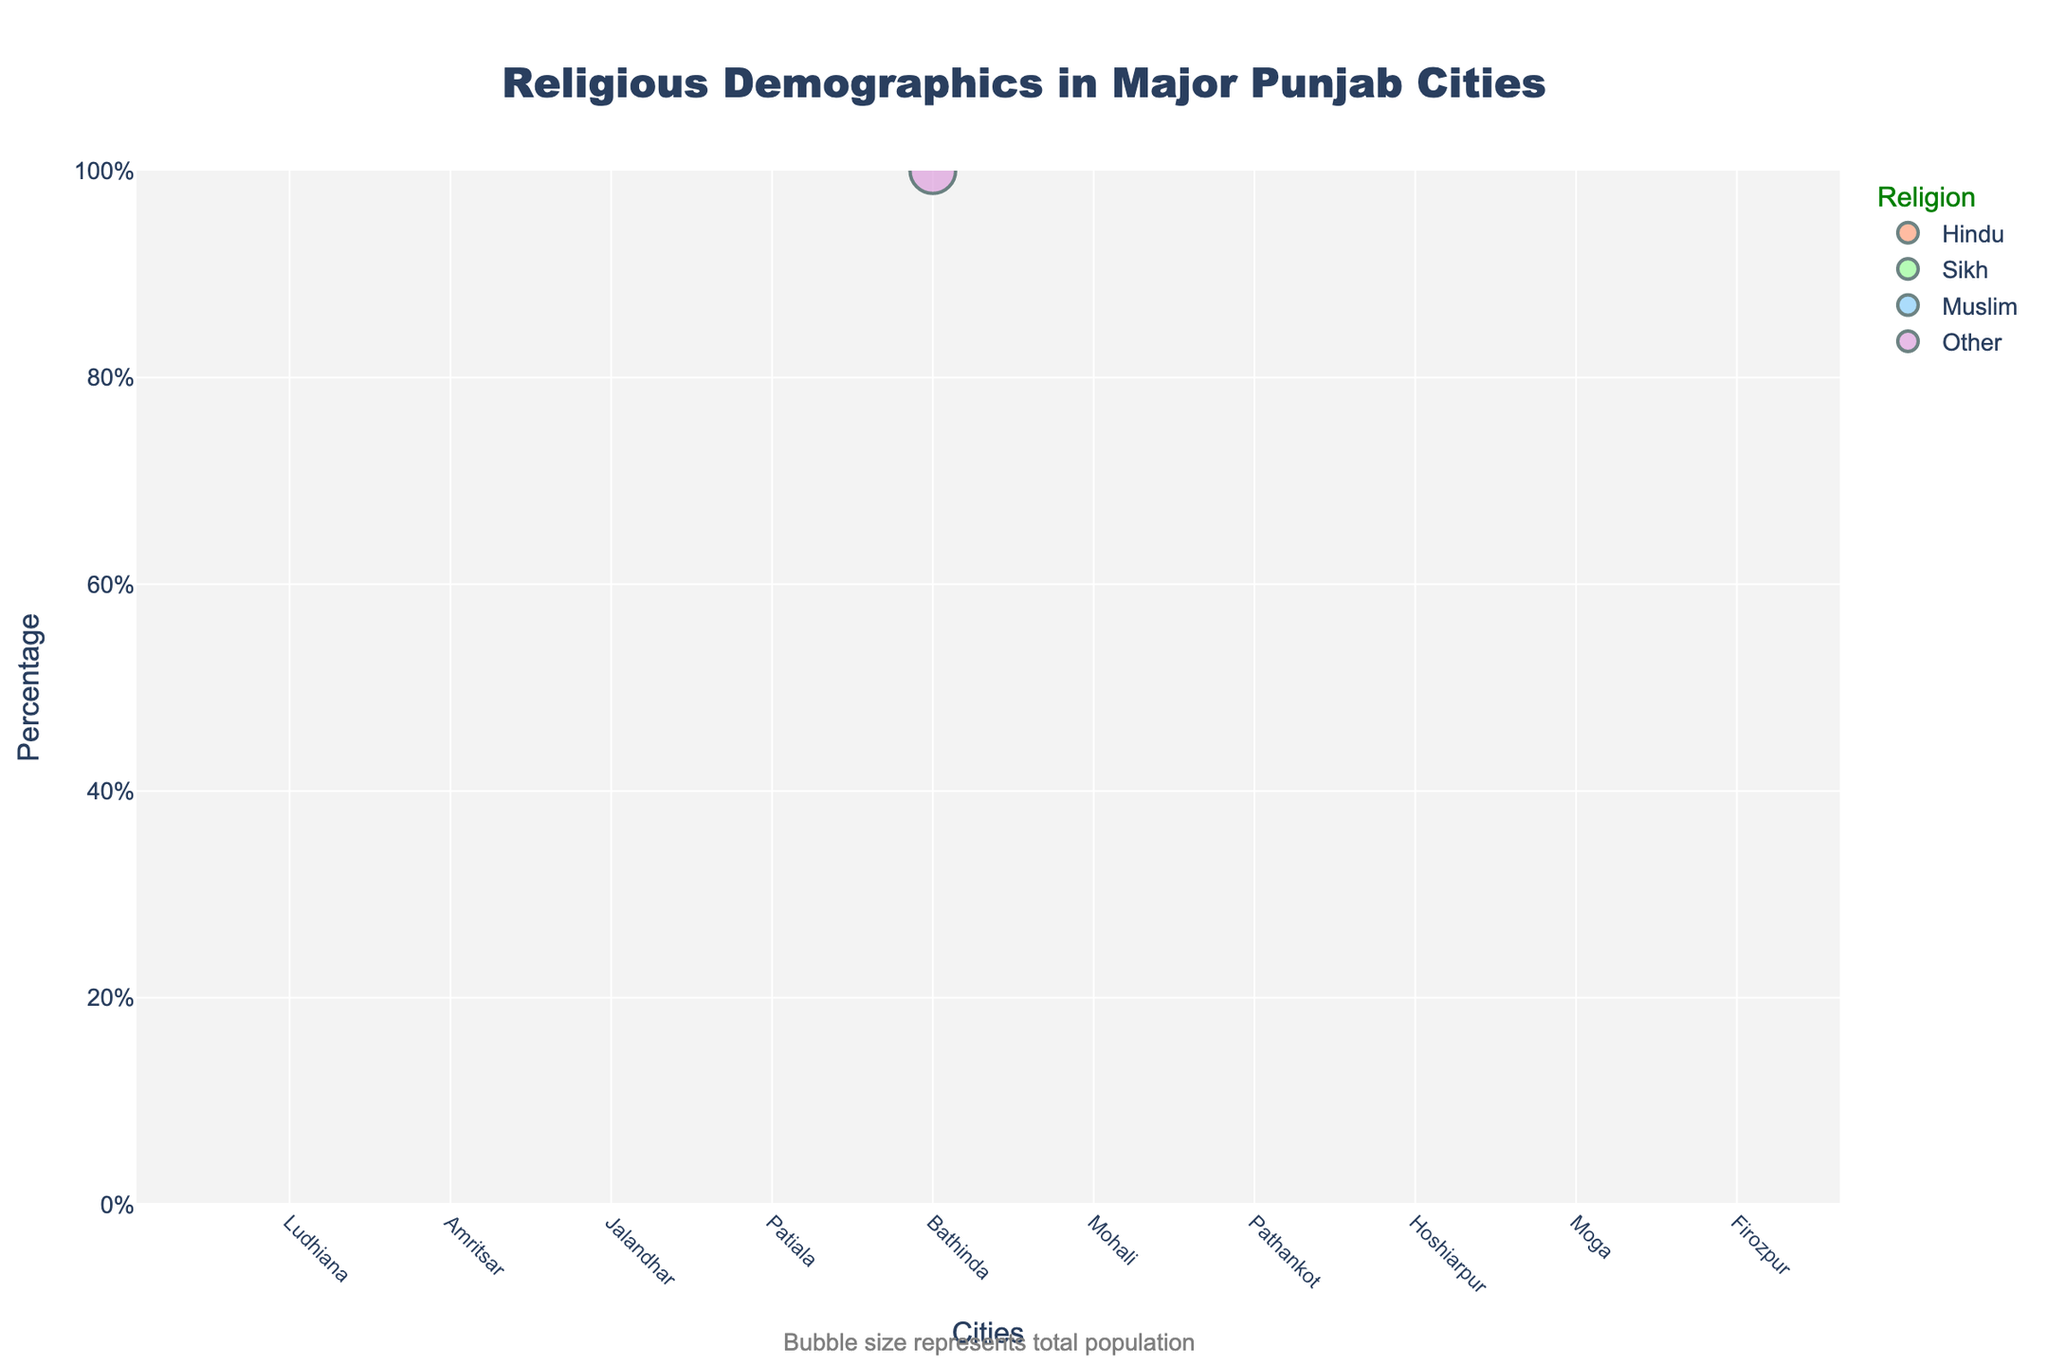Which department has the highest productivity score? By looking at the first subplot "Productivity vs. Satisfaction", we can identify the department with the highest bubble on the y-axis (Productivity Score). The highest point corresponds to Sales with a productivity score of 92.
Answer: Sales What is the title of the figure? The title is located at the top center of the figure, indicating the overall purpose of the plots. The title reads "Employee Productivity and Satisfaction Analysis".
Answer: Employee Productivity and Satisfaction Analysis How many departments have a satisfaction level greater than 8? In the first subplot "Productivity vs. Satisfaction", look at the x-axis (Satisfaction Level) to identify departments with values greater than 8. Sales, Human Resources, and Research & Development have satisfaction levels above 8.
Answer: 3 Which department has the smallest team size, and what is their productivity score? Refer to the second subplot "Team Size vs. Productivity" and identify the smallest bubble on the x-axis (Team Size). The smallest bubble belongs to Human Resources with a team size of 8 and a productivity score of 79.
Answer: Human Resources, 79 How does the productivity score of IT compare to Marketing? Locate the IT and Marketing bubbles in the first subplot. The productivity score for IT is 90, and for Marketing, it is 85. Therefore, IT has a higher productivity score than Marketing.
Answer: IT is higher What is the average satisfaction level of Operations and Finance? Find the satisfaction levels for Operations (7.5) and Finance (7.1) from the first subplot. Calculate the average: (7.5 + 7.1) / 2 = 7.3.
Answer: 7.3 Which department has the most considerable bubble size in the first subplot and why? In the first subplot, bubble size is determined by the team size. The largest bubble corresponds to Customer Service with a team size of 20.
Answer: Customer Service Is there an overall correlation between satisfaction level and productivity score across departments? In the first subplot, examine whether higher satisfaction levels generally correspond to higher productivity scores. There is a discernible positive correlation, where departments with higher satisfaction levels tend to have higher productivity scores. However, exceptions like Customer Service, which has a lower productivity score, exist.
Answer: Yes, generally positive What is the relationship between team size and productivity in the second subplot? Observe the bubble distribution in the second subplot "Team Size vs. Productivity". There is no clear linear relationship as some departments with larger team sizes such as Customer Service have lower productivity scores, whereas others like Sales with a mid-size team have high scores.
Answer: No clear linear relationship How many departments have a productivity score of 85 or higher? Check the y-axis in both subplots to count the number of departments with productivity scores 85 or higher. These are Marketing, Sales, Operations, IT, and Research & Development.
Answer: 5 